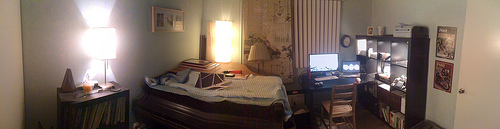Describe the type of bedding on the bed. The bed is made with a variety of bedding, including a striped duvet cover in shades of blue and an assortment of pillows. The bedding arrangement looks cozy and inviting, suggesting comfort is a priority in this space. 